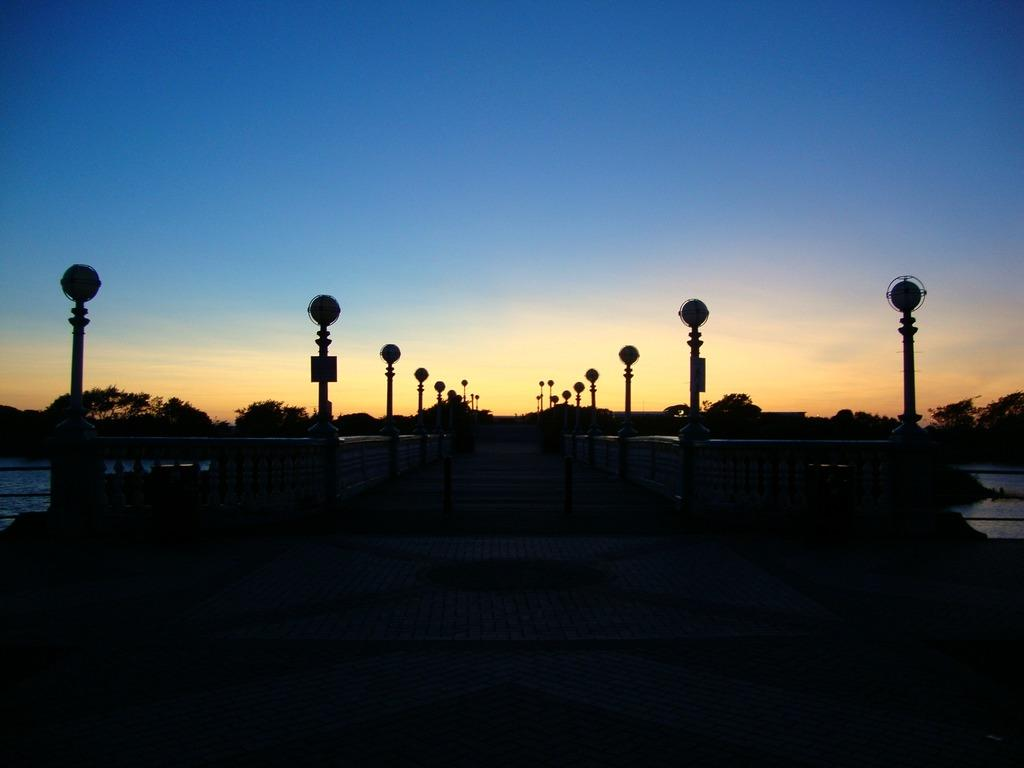What is the color or lighting condition at the bottom of the image? The bottom of the image is dark. What can be seen in the background of the image? There are poles, trees, water, and clouds in the sky in the sky in the background of the image. How many mice are sitting on the boot in the image? There are no mice or boots present in the image. What color is the blood on the ground in the image? There is no blood present in the image. 